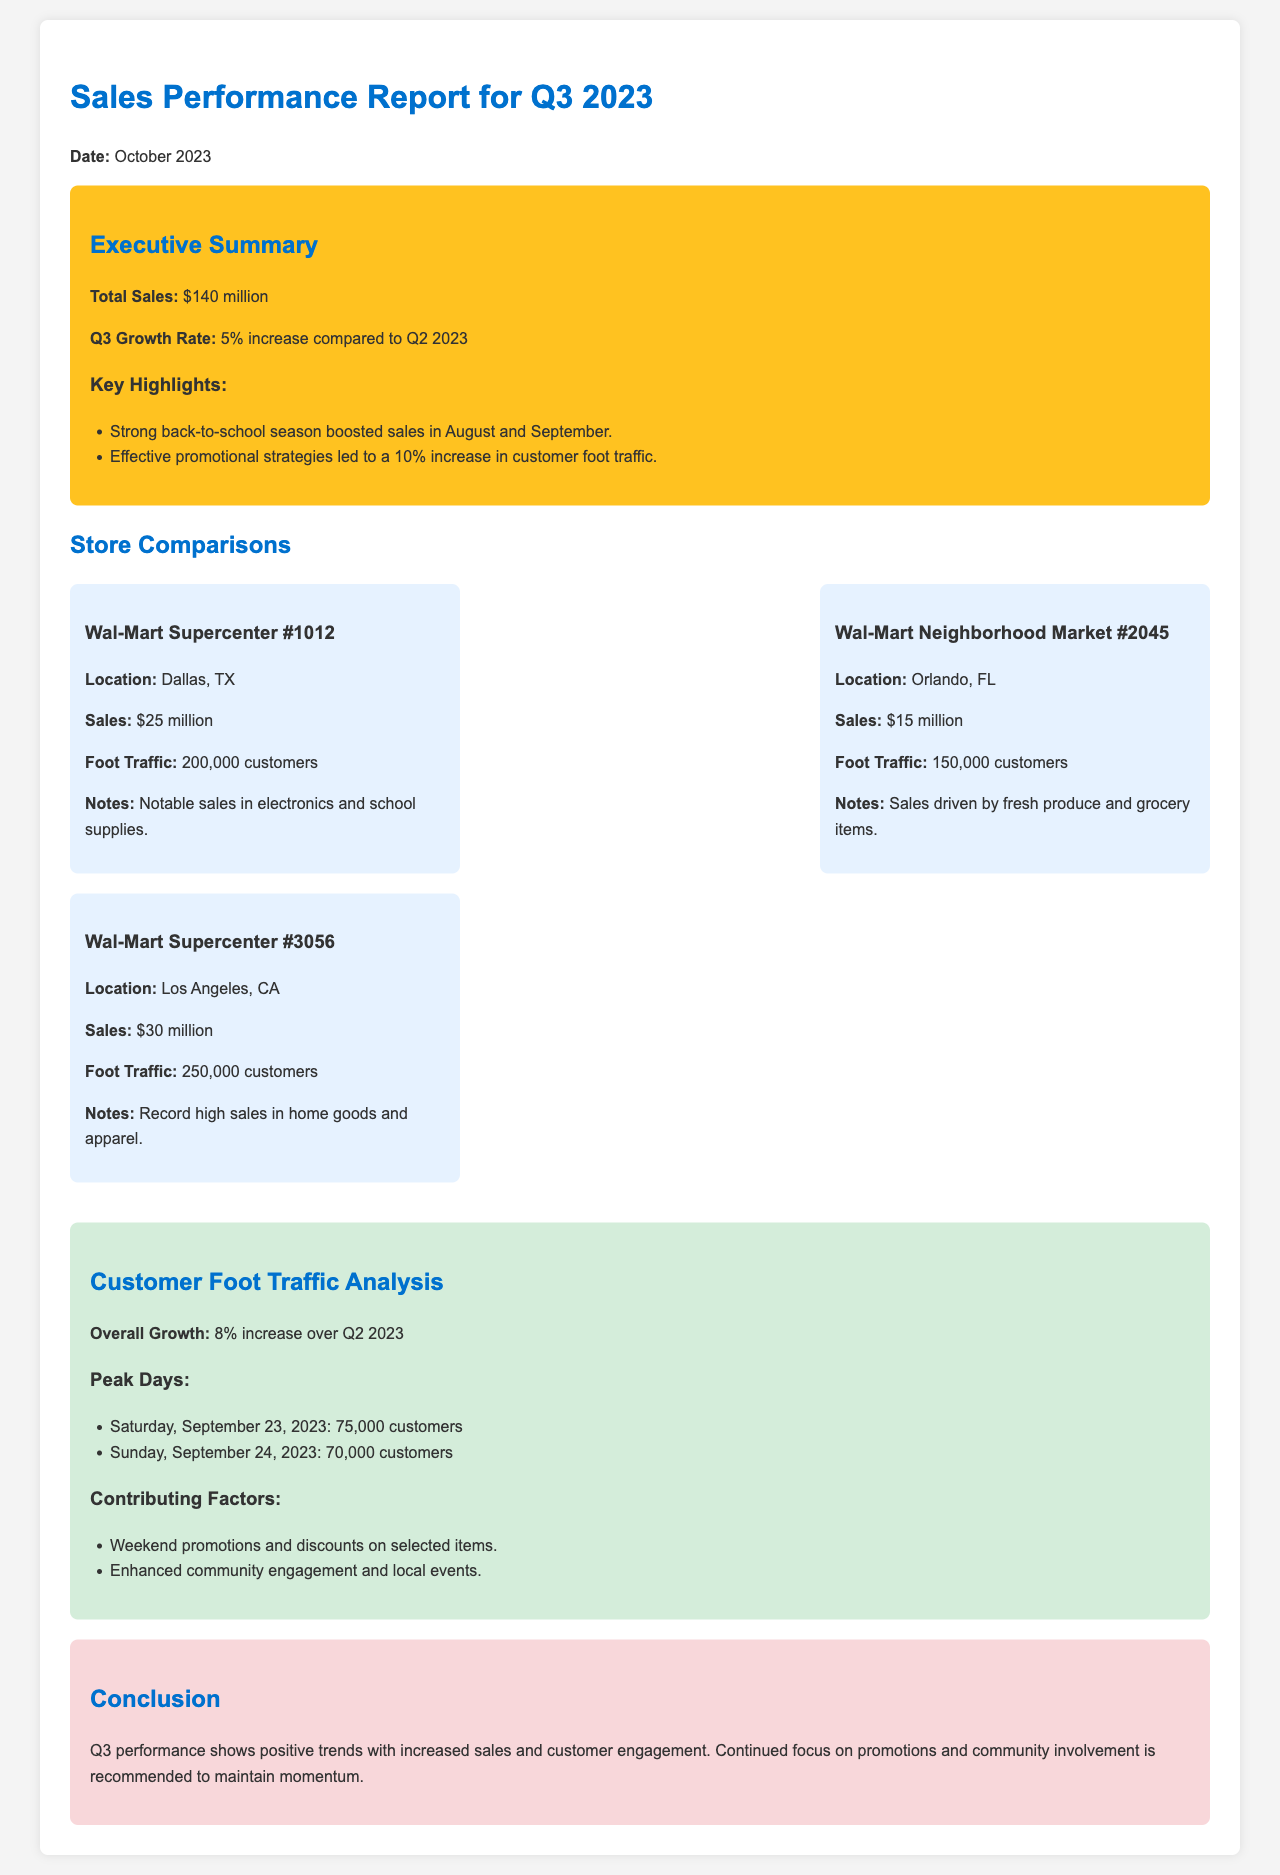What was the total sales for Q3 2023? The total sales reported in Q3 2023 is stated as $140 million.
Answer: $140 million What was the Q3 growth rate compared to Q2 2023? The document specifies a 5% increase in sales compared to Q2 2023.
Answer: 5% Which store had the highest foot traffic? Foot traffic data indicates that Wal-Mart Supercenter #3056 in Los Angeles, CA had 250,000 customers.
Answer: 250,000 customers What contributed to the sales boost during Q3? The document notes that the strong back-to-school season and effective promotional strategies boosted sales.
Answer: Back-to-school season and promotional strategies What were the peak days for customer foot traffic? The document mentions Saturday, September 23, 2023 and Sunday, September 24, 2023 as peak days.
Answer: September 23 and 24, 2023 Which store had the notable sales in electronics and school supplies? Wal-Mart Supercenter #1012 in Dallas, TX is mentioned for notable sales in those categories.
Answer: Wal-Mart Supercenter #1012 What was the increase in overall customer foot traffic over Q2 2023? The report states an overall growth of 8% in customer foot traffic compared to Q2 2023.
Answer: 8% What is the conclusion regarding Q3 performance? The conclusion states there are positive trends with increased sales and customer engagement.
Answer: Positive trends with increased sales and engagement 